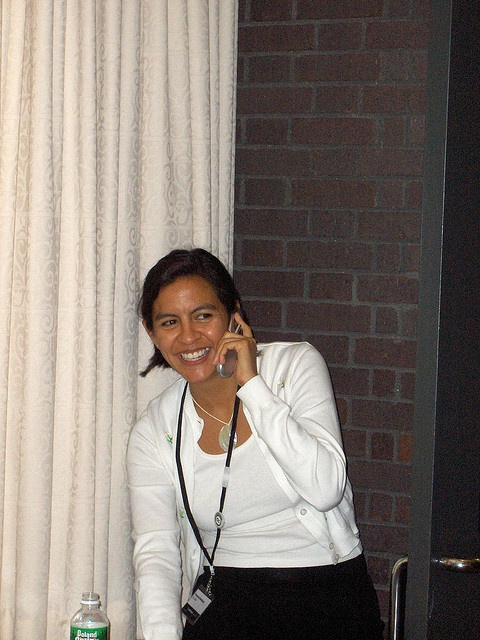Describe the objects in this image and their specific colors. I can see people in darkgray, lightgray, black, and brown tones, bottle in darkgray, lightgray, gray, and darkgreen tones, and cell phone in darkgray, brown, and maroon tones in this image. 